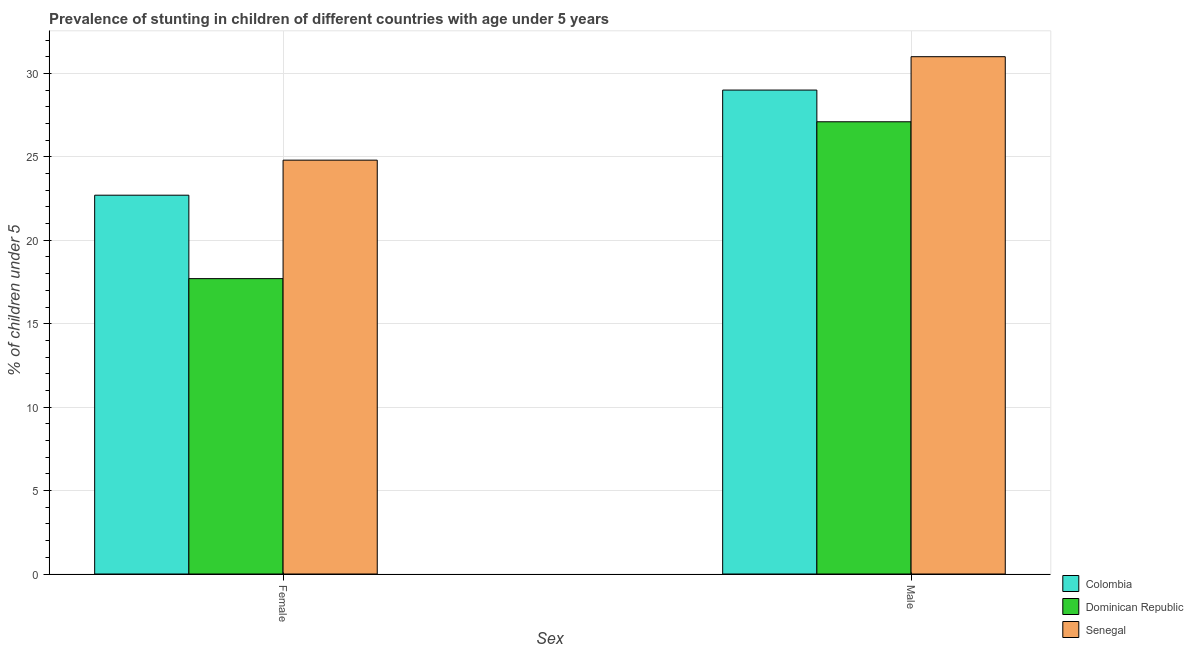How many groups of bars are there?
Keep it short and to the point. 2. Are the number of bars per tick equal to the number of legend labels?
Keep it short and to the point. Yes. What is the percentage of stunted male children in Dominican Republic?
Ensure brevity in your answer.  27.1. Across all countries, what is the minimum percentage of stunted male children?
Your answer should be very brief. 27.1. In which country was the percentage of stunted female children maximum?
Your answer should be very brief. Senegal. In which country was the percentage of stunted female children minimum?
Give a very brief answer. Dominican Republic. What is the total percentage of stunted male children in the graph?
Keep it short and to the point. 87.1. What is the difference between the percentage of stunted female children in Colombia and that in Senegal?
Your answer should be very brief. -2.1. What is the difference between the percentage of stunted male children in Senegal and the percentage of stunted female children in Colombia?
Give a very brief answer. 8.3. What is the average percentage of stunted male children per country?
Offer a very short reply. 29.03. What is the difference between the percentage of stunted male children and percentage of stunted female children in Senegal?
Your answer should be compact. 6.2. What is the ratio of the percentage of stunted female children in Dominican Republic to that in Senegal?
Your response must be concise. 0.71. Is the percentage of stunted female children in Senegal less than that in Dominican Republic?
Offer a very short reply. No. In how many countries, is the percentage of stunted female children greater than the average percentage of stunted female children taken over all countries?
Provide a succinct answer. 2. What does the 2nd bar from the left in Female represents?
Give a very brief answer. Dominican Republic. What does the 1st bar from the right in Male represents?
Your response must be concise. Senegal. What is the difference between two consecutive major ticks on the Y-axis?
Make the answer very short. 5. Are the values on the major ticks of Y-axis written in scientific E-notation?
Give a very brief answer. No. Where does the legend appear in the graph?
Ensure brevity in your answer.  Bottom right. What is the title of the graph?
Your response must be concise. Prevalence of stunting in children of different countries with age under 5 years. What is the label or title of the X-axis?
Provide a short and direct response. Sex. What is the label or title of the Y-axis?
Your answer should be very brief.  % of children under 5. What is the  % of children under 5 of Colombia in Female?
Provide a short and direct response. 22.7. What is the  % of children under 5 of Dominican Republic in Female?
Offer a very short reply. 17.7. What is the  % of children under 5 in Senegal in Female?
Your answer should be compact. 24.8. What is the  % of children under 5 of Dominican Republic in Male?
Provide a short and direct response. 27.1. Across all Sex, what is the maximum  % of children under 5 in Dominican Republic?
Provide a succinct answer. 27.1. Across all Sex, what is the minimum  % of children under 5 in Colombia?
Offer a very short reply. 22.7. Across all Sex, what is the minimum  % of children under 5 in Dominican Republic?
Make the answer very short. 17.7. Across all Sex, what is the minimum  % of children under 5 of Senegal?
Keep it short and to the point. 24.8. What is the total  % of children under 5 of Colombia in the graph?
Provide a short and direct response. 51.7. What is the total  % of children under 5 of Dominican Republic in the graph?
Offer a terse response. 44.8. What is the total  % of children under 5 of Senegal in the graph?
Ensure brevity in your answer.  55.8. What is the difference between the  % of children under 5 of Dominican Republic in Female and that in Male?
Your answer should be compact. -9.4. What is the difference between the  % of children under 5 of Colombia in Female and the  % of children under 5 of Senegal in Male?
Ensure brevity in your answer.  -8.3. What is the average  % of children under 5 of Colombia per Sex?
Offer a very short reply. 25.85. What is the average  % of children under 5 in Dominican Republic per Sex?
Offer a terse response. 22.4. What is the average  % of children under 5 of Senegal per Sex?
Offer a terse response. 27.9. What is the difference between the  % of children under 5 of Colombia and  % of children under 5 of Dominican Republic in Female?
Give a very brief answer. 5. What is the difference between the  % of children under 5 in Dominican Republic and  % of children under 5 in Senegal in Female?
Make the answer very short. -7.1. What is the difference between the  % of children under 5 of Colombia and  % of children under 5 of Dominican Republic in Male?
Offer a terse response. 1.9. What is the difference between the  % of children under 5 of Colombia and  % of children under 5 of Senegal in Male?
Provide a succinct answer. -2. What is the ratio of the  % of children under 5 of Colombia in Female to that in Male?
Offer a very short reply. 0.78. What is the ratio of the  % of children under 5 in Dominican Republic in Female to that in Male?
Your answer should be very brief. 0.65. What is the ratio of the  % of children under 5 in Senegal in Female to that in Male?
Your answer should be very brief. 0.8. What is the difference between the highest and the second highest  % of children under 5 in Dominican Republic?
Offer a very short reply. 9.4. What is the difference between the highest and the lowest  % of children under 5 in Colombia?
Give a very brief answer. 6.3. What is the difference between the highest and the lowest  % of children under 5 of Dominican Republic?
Your response must be concise. 9.4. What is the difference between the highest and the lowest  % of children under 5 of Senegal?
Your answer should be compact. 6.2. 